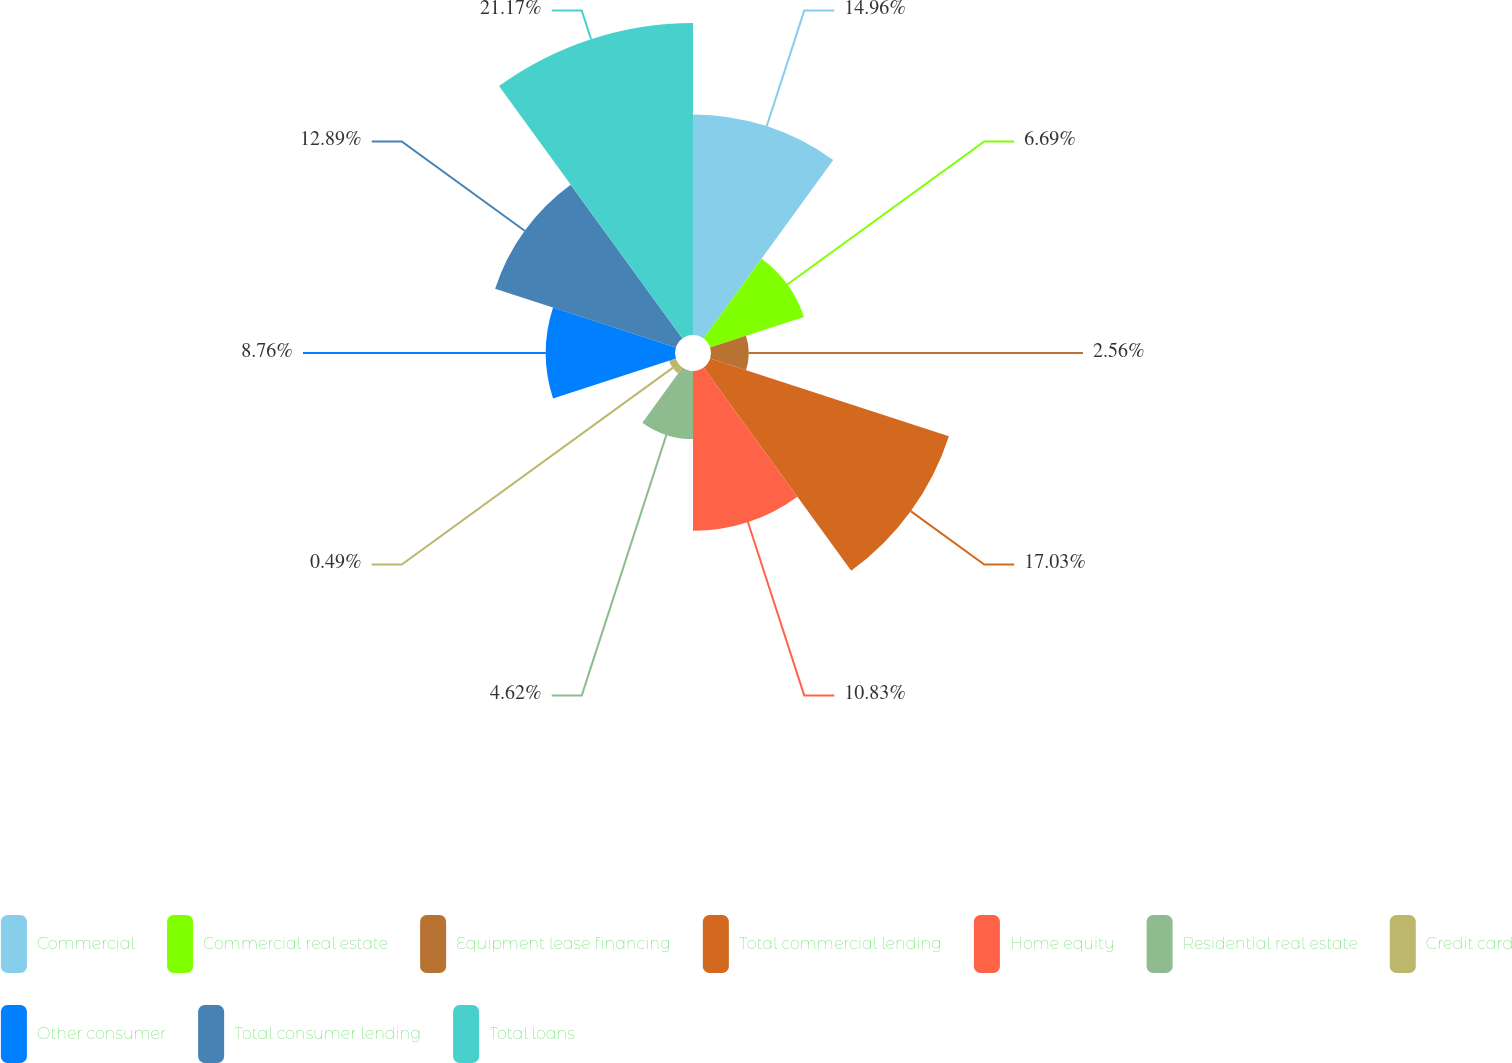Convert chart. <chart><loc_0><loc_0><loc_500><loc_500><pie_chart><fcel>Commercial<fcel>Commercial real estate<fcel>Equipment lease financing<fcel>Total commercial lending<fcel>Home equity<fcel>Residential real estate<fcel>Credit card<fcel>Other consumer<fcel>Total consumer lending<fcel>Total loans<nl><fcel>14.96%<fcel>6.69%<fcel>2.56%<fcel>17.03%<fcel>10.83%<fcel>4.62%<fcel>0.49%<fcel>8.76%<fcel>12.89%<fcel>21.16%<nl></chart> 